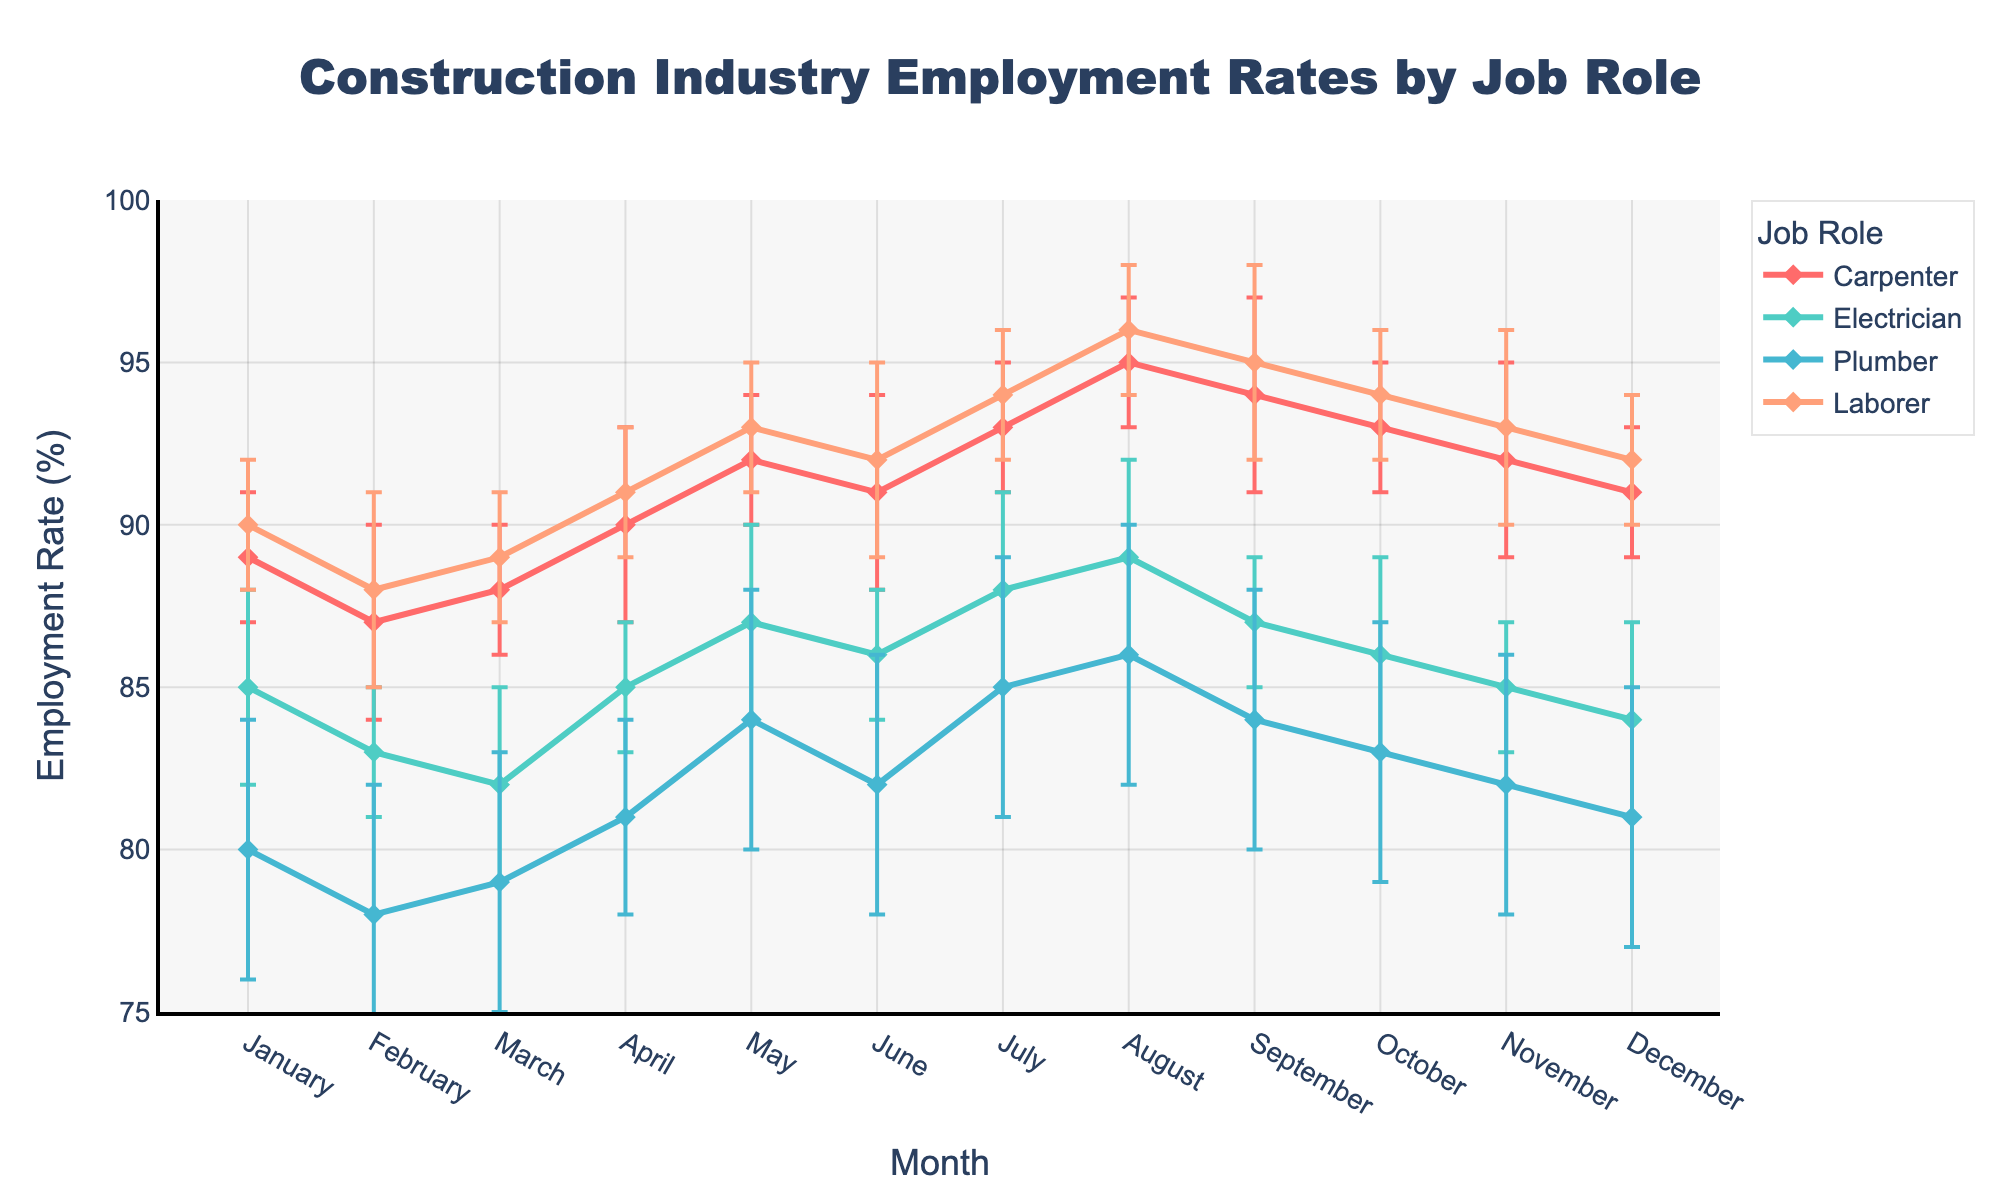What is the title of the figure? The title of the figure is usually displayed at the top of the plot. In this case, the title is clearly written at the top of the plot.
Answer: Construction Industry Employment Rates by Job Role Which job role had the highest employment rate in August? Look at the data points for August and compare the employment rates for all job roles. The highest point corresponds to the highest employment rate.
Answer: Laborer What is the employment rate for Electricians in May? Find the data point for Electricians in May on the figure. The y-axis value of this point represents the employment rate.
Answer: 87% Across which months did Carpenters have an increasing trend in employment rates? Observe the line representing Carpenters and note the months where the line has an upward slope. Identify these months from the x-axis.
Answer: From February to May and July to August What is the average employment rate for Plumbers from January to December? Add up all the employment rates for Plumbers from January to December and then divide by the number of months (12).
Answer: (80 + 78 + 79 + 81 + 84 + 82 + 85 + 86 + 84 + 83 + 82 + 81) / 12 = 82.08% Which job role had the least variation in employment rates throughout the year? Observe the range of employment rates (minimum to maximum) for each job role throughout the year. The job role with the smallest range has the least variation.
Answer: Laborer In which month did Electricians experience their lowest employment rate? Look at the line representing Electricians and find the lowest data point. Identify the corresponding month from the x-axis.
Answer: March What is the range of employment rates for Laborers in this figure? Identify the minimum and maximum employment rates for Laborers from the plot and calculate the difference between them.
Answer: 96% - 88% = 8% 